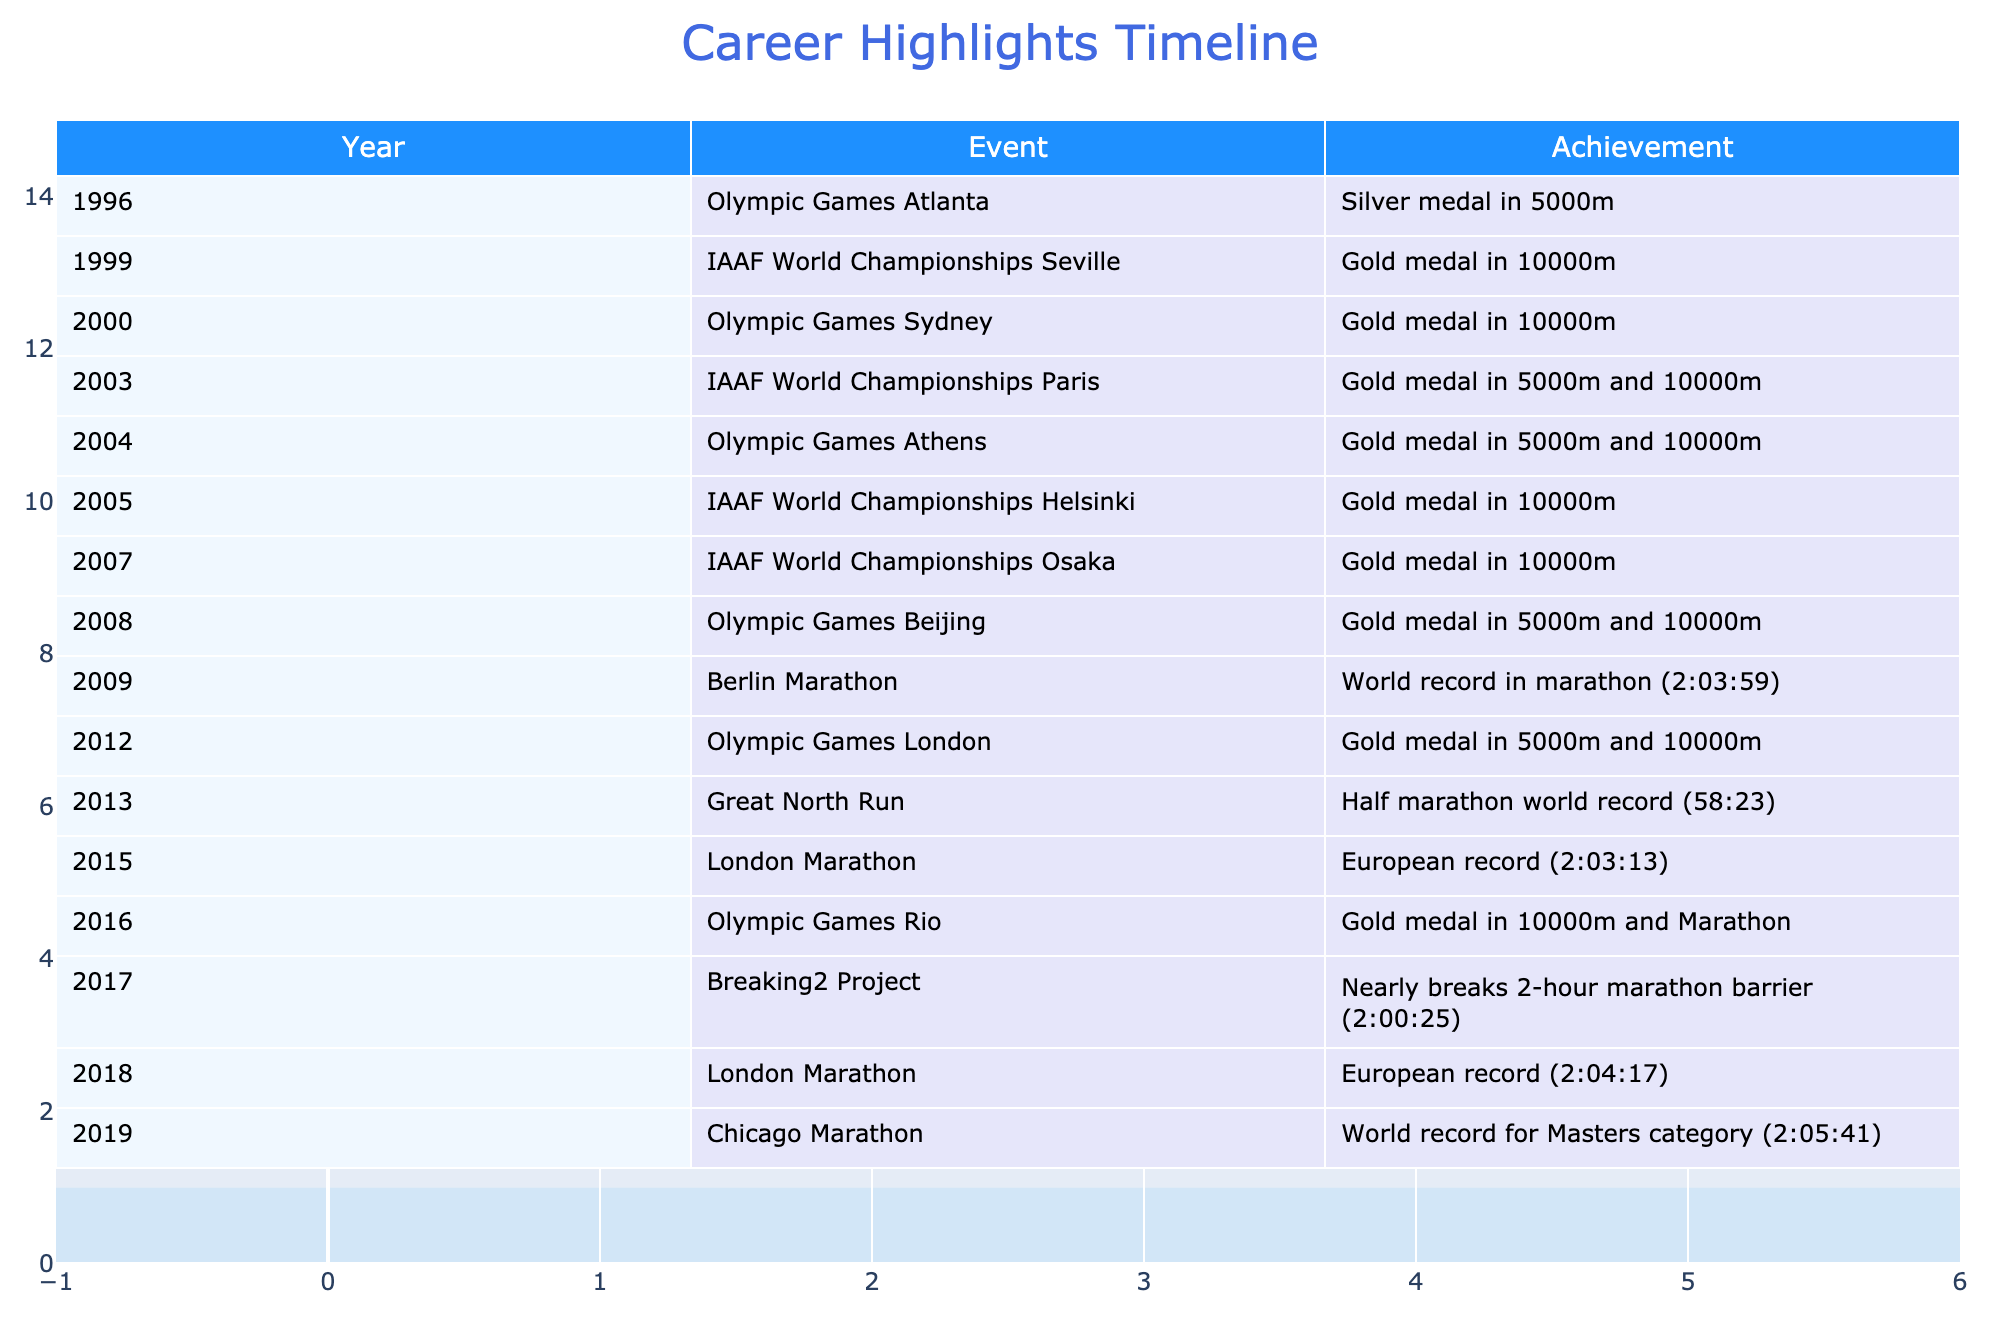What event did the retired champion achieve a silver medal in? The table lists the 1996 Olympic Games in Atlanta as the year when the retired champion won a silver medal in the 5000m event.
Answer: Silver medal in 5000m In which year did the retired champion first win gold at the Olympic Games? The table shows two Olympic Games appearances: 1996 with a silver medal and 2000 where the champion won the gold medal in the 10000m event. Thus, 2000 is the first year for Olympic gold.
Answer: 2000 How many times did the champion win gold medals in the 10000m event? By examining the table, the retired champion won gold in the 10000m event in the years: 2000, 2003, 2004, 2005, 2007, and 2016. Counting these, there are a total of six occurrences.
Answer: 6 Is it true that the champion set a world record in the marathon? The table indicates that in 2009, the retired champion set a world record in the marathon with a time of 2:03:59, confirming that the statement is true.
Answer: Yes What was the champion's best marathon time, and in which year was it achieved? Looking closely at the table, the world record of 2:03:59 was set in 2009 and represents the champion's best marathon time. This event did not occur in any later years, which confirms it as the best.
Answer: 2:03:59 in 2009 In which events did the champion win gold medals during the 2012 Olympic Games? According to the table, in the 2012 Olympic Games in London, the retired champion achieved gold medals in both the 5000m and 10000m events, indicating a successful performance across both distances that year.
Answer: 5000m and 10000m What is the average number of gold medals won in the 5000m event throughout the champion's career leading up to 2019? The table indicates gold medals won in the 5000m in 2003, 2004, 2008, 2012, and 2016, totaling five gold medals. Dividing by the five events where medals were won gives an average of 5/5 = 1 gold medal per event related to 5000m.
Answer: 1 How many years separated the champion's world record for the marathon and the world record for the half marathon? The table shows that the world record for the marathon was set in 2009 and the half marathon world record in 2013. Counting years from 2009 to 2013 gives a separation of four years.
Answer: 4 years 